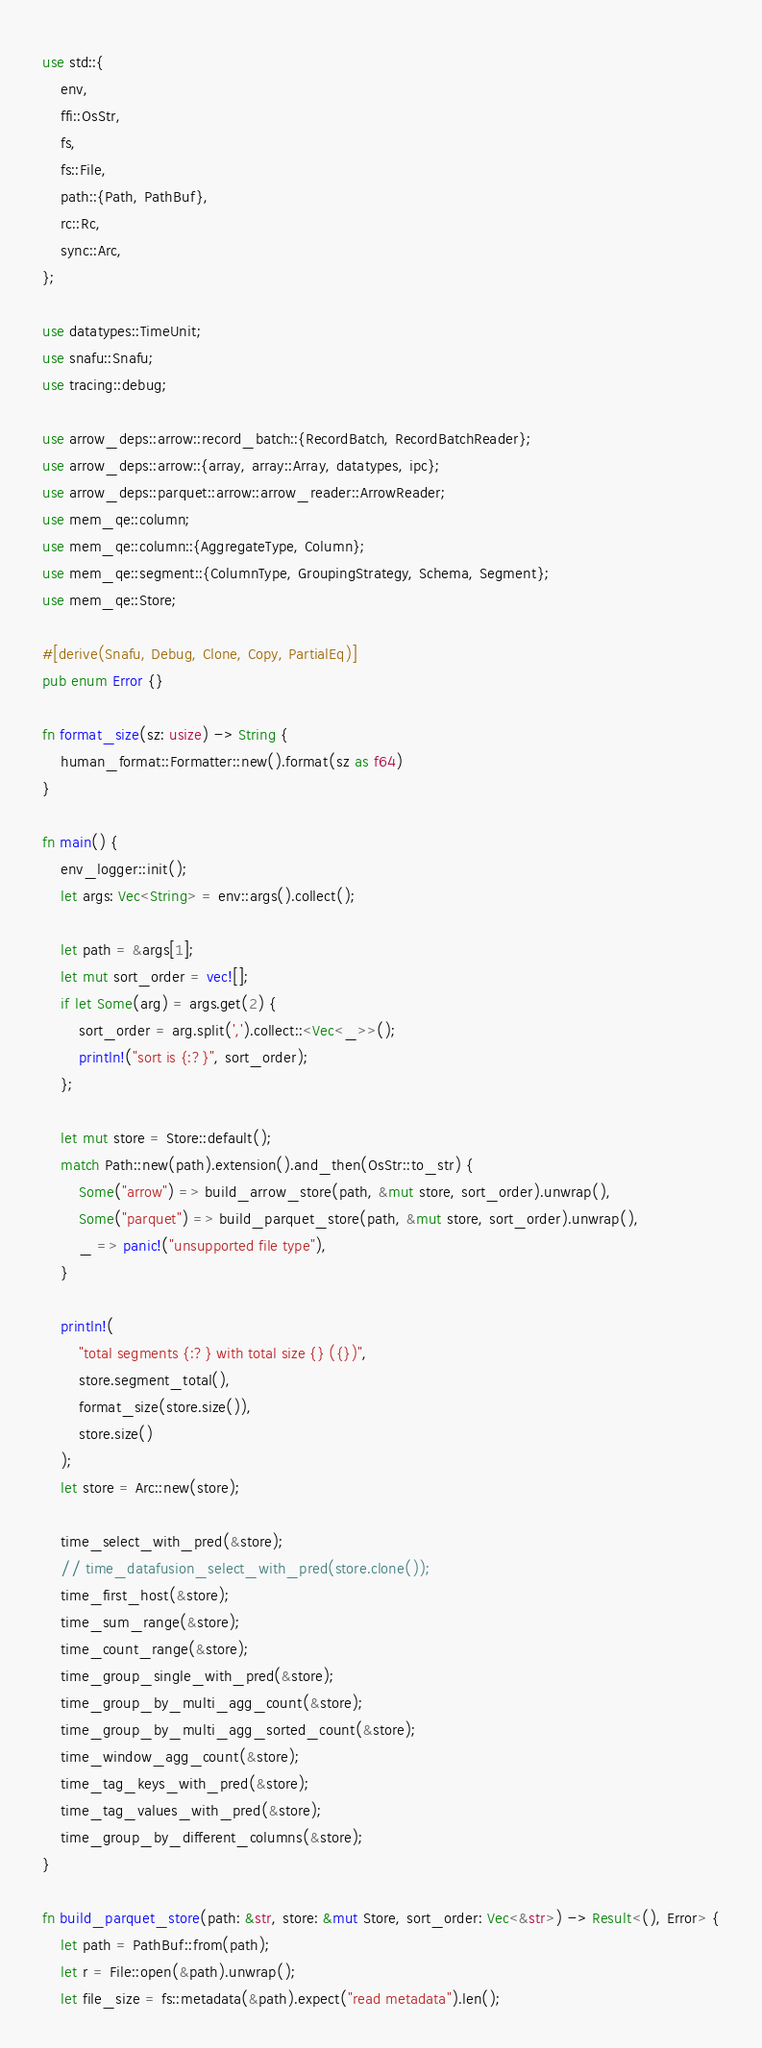<code> <loc_0><loc_0><loc_500><loc_500><_Rust_>use std::{
    env,
    ffi::OsStr,
    fs,
    fs::File,
    path::{Path, PathBuf},
    rc::Rc,
    sync::Arc,
};

use datatypes::TimeUnit;
use snafu::Snafu;
use tracing::debug;

use arrow_deps::arrow::record_batch::{RecordBatch, RecordBatchReader};
use arrow_deps::arrow::{array, array::Array, datatypes, ipc};
use arrow_deps::parquet::arrow::arrow_reader::ArrowReader;
use mem_qe::column;
use mem_qe::column::{AggregateType, Column};
use mem_qe::segment::{ColumnType, GroupingStrategy, Schema, Segment};
use mem_qe::Store;

#[derive(Snafu, Debug, Clone, Copy, PartialEq)]
pub enum Error {}

fn format_size(sz: usize) -> String {
    human_format::Formatter::new().format(sz as f64)
}

fn main() {
    env_logger::init();
    let args: Vec<String> = env::args().collect();

    let path = &args[1];
    let mut sort_order = vec![];
    if let Some(arg) = args.get(2) {
        sort_order = arg.split(',').collect::<Vec<_>>();
        println!("sort is {:?}", sort_order);
    };

    let mut store = Store::default();
    match Path::new(path).extension().and_then(OsStr::to_str) {
        Some("arrow") => build_arrow_store(path, &mut store, sort_order).unwrap(),
        Some("parquet") => build_parquet_store(path, &mut store, sort_order).unwrap(),
        _ => panic!("unsupported file type"),
    }

    println!(
        "total segments {:?} with total size {} ({})",
        store.segment_total(),
        format_size(store.size()),
        store.size()
    );
    let store = Arc::new(store);

    time_select_with_pred(&store);
    // time_datafusion_select_with_pred(store.clone());
    time_first_host(&store);
    time_sum_range(&store);
    time_count_range(&store);
    time_group_single_with_pred(&store);
    time_group_by_multi_agg_count(&store);
    time_group_by_multi_agg_sorted_count(&store);
    time_window_agg_count(&store);
    time_tag_keys_with_pred(&store);
    time_tag_values_with_pred(&store);
    time_group_by_different_columns(&store);
}

fn build_parquet_store(path: &str, store: &mut Store, sort_order: Vec<&str>) -> Result<(), Error> {
    let path = PathBuf::from(path);
    let r = File::open(&path).unwrap();
    let file_size = fs::metadata(&path).expect("read metadata").len();</code> 